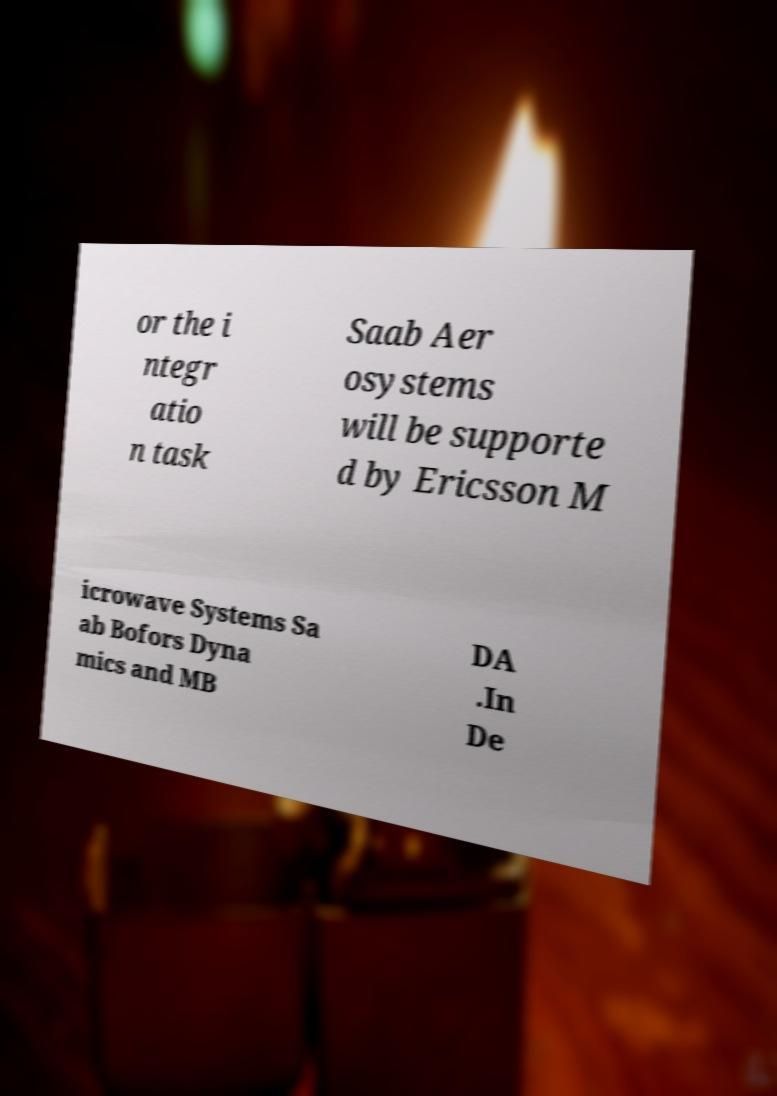There's text embedded in this image that I need extracted. Can you transcribe it verbatim? or the i ntegr atio n task Saab Aer osystems will be supporte d by Ericsson M icrowave Systems Sa ab Bofors Dyna mics and MB DA .In De 